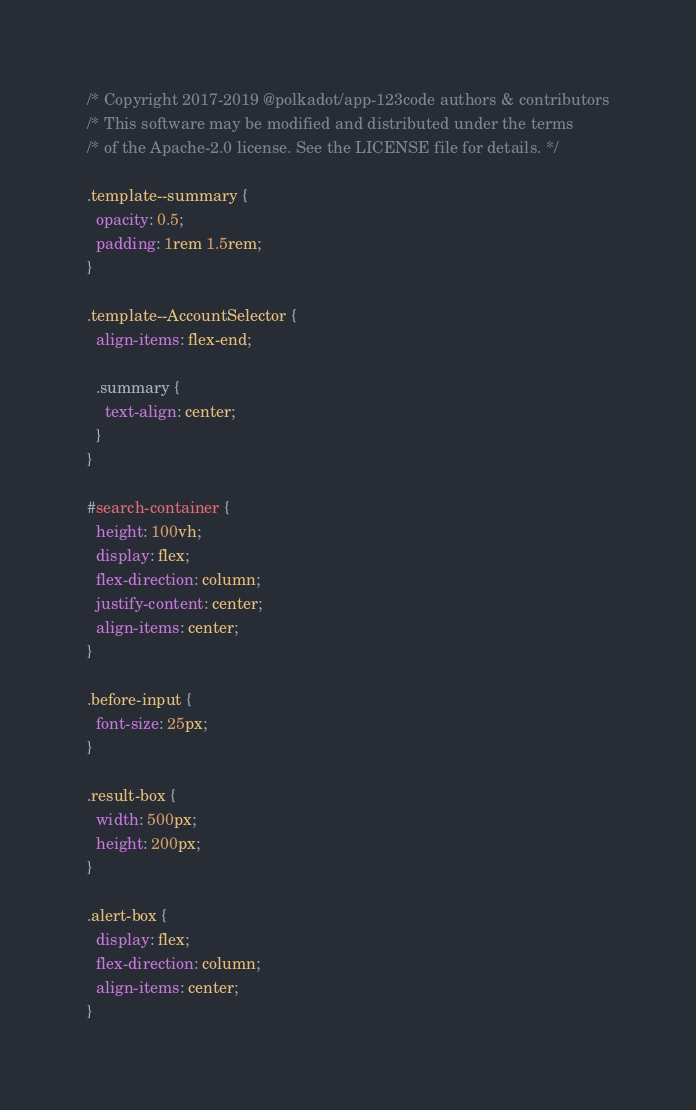<code> <loc_0><loc_0><loc_500><loc_500><_CSS_>/* Copyright 2017-2019 @polkadot/app-123code authors & contributors
/* This software may be modified and distributed under the terms
/* of the Apache-2.0 license. See the LICENSE file for details. */

.template--summary {
  opacity: 0.5;
  padding: 1rem 1.5rem;
}

.template--AccountSelector {
  align-items: flex-end;

  .summary {
    text-align: center;
  }
}

#search-container {
  height: 100vh;
  display: flex;
  flex-direction: column;
  justify-content: center;
  align-items: center;
}

.before-input {
  font-size: 25px;
}

.result-box {
  width: 500px;
  height: 200px;
}

.alert-box {
  display: flex;
  flex-direction: column;
  align-items: center;
}
</code> 